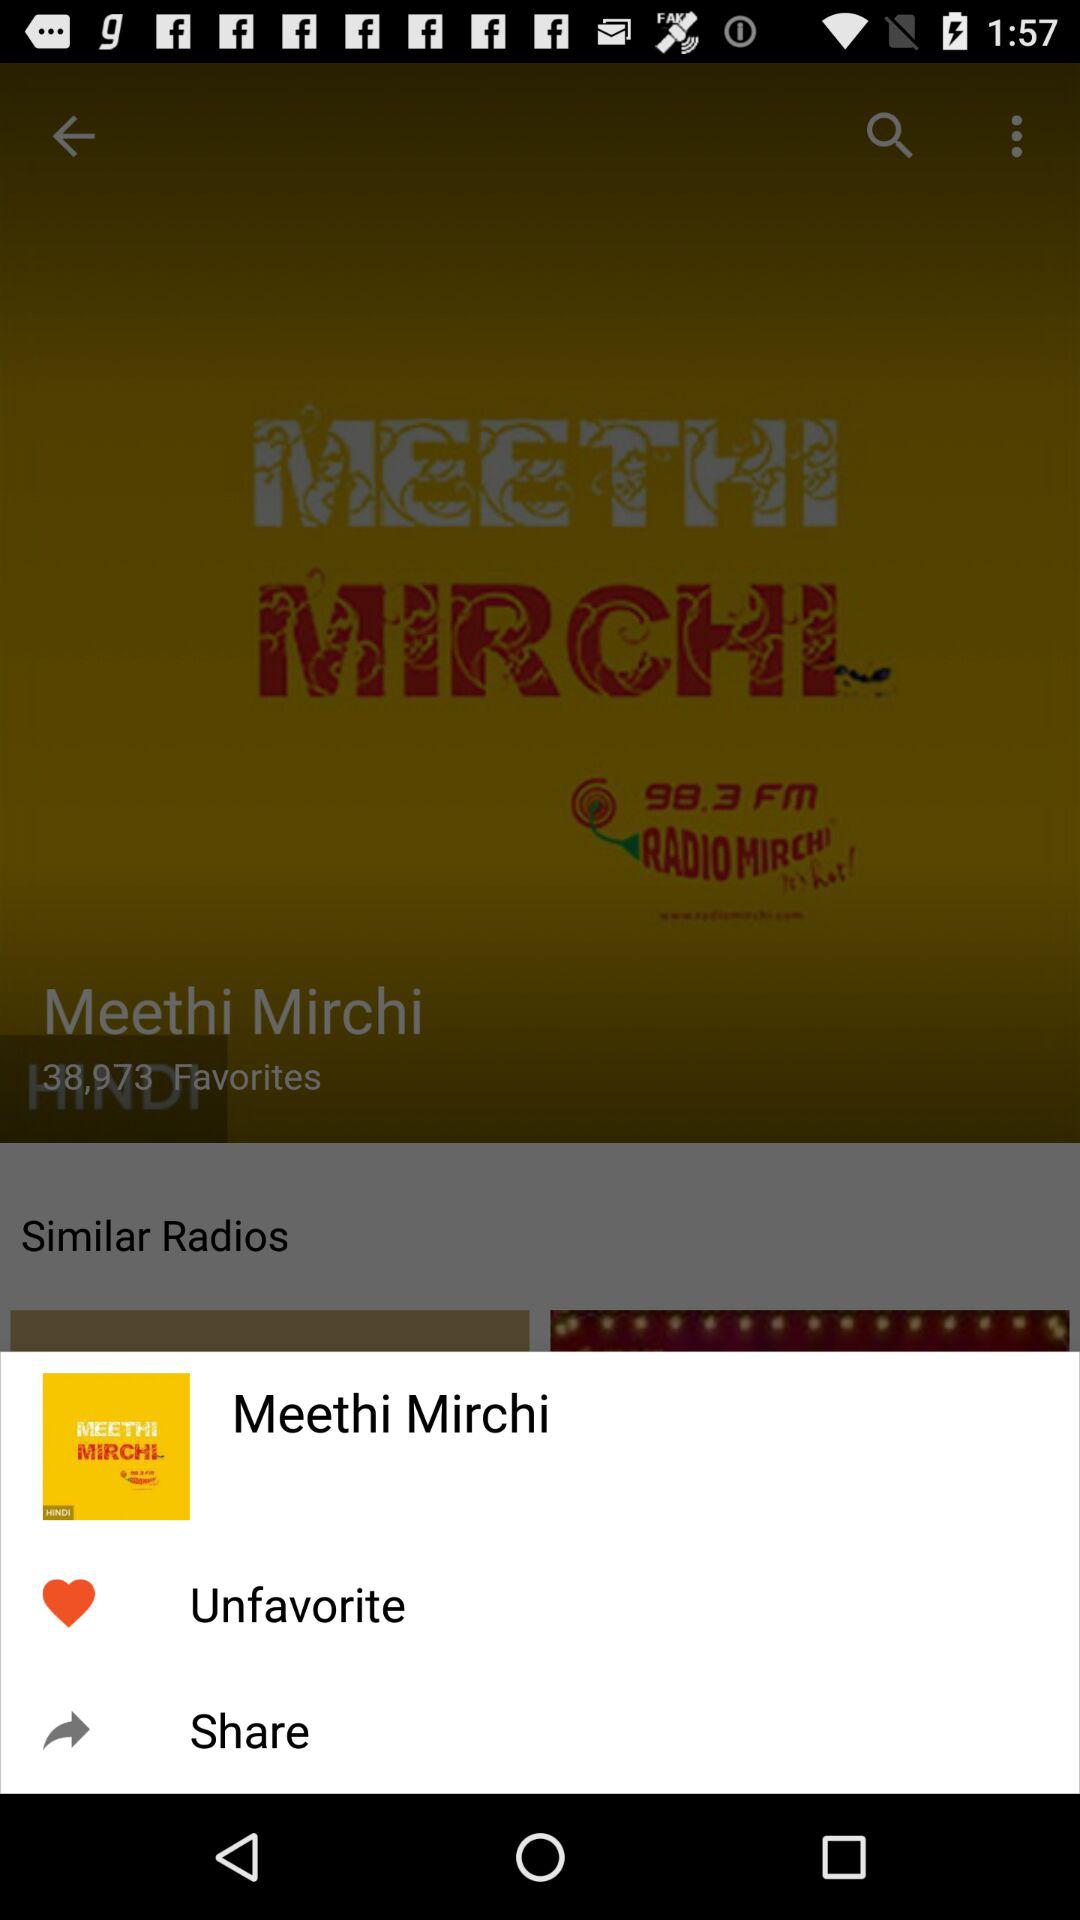What is the name of the radio station? The name of the radio station is "RADIO MIRCHI". 